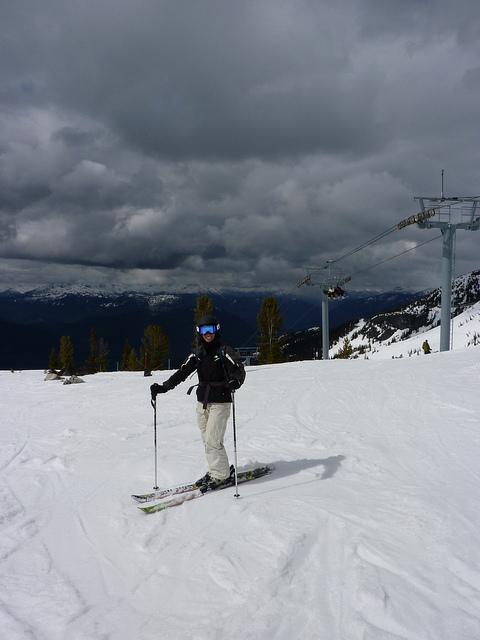Is it going to snow?
Write a very short answer. Yes. Is it cloudy?
Be succinct. Yes. Is it going to snow more?
Short answer required. Yes. How does one get to the top of this mountain?
Be succinct. Ski lift. 